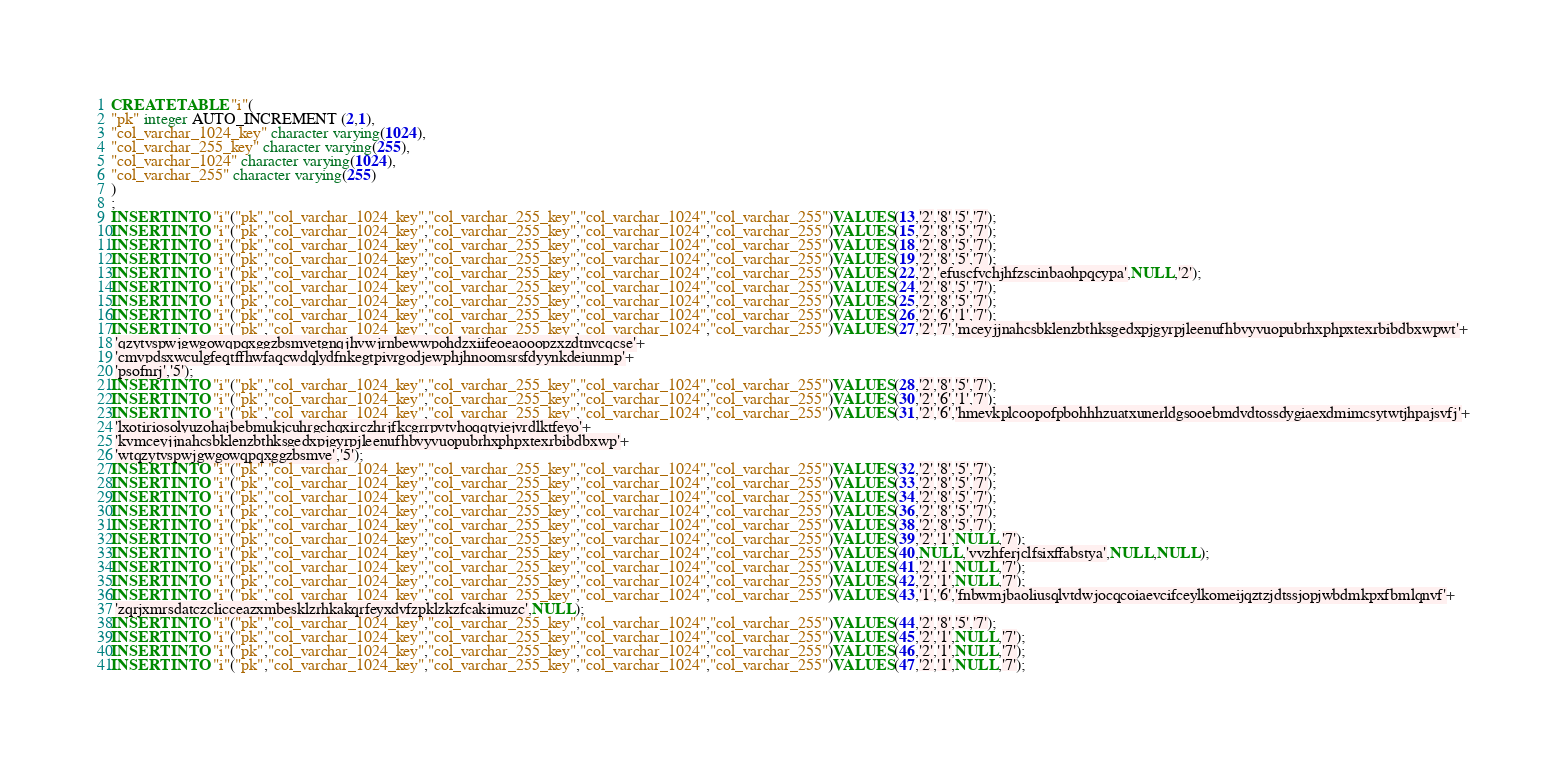Convert code to text. <code><loc_0><loc_0><loc_500><loc_500><_SQL_>CREATE TABLE "i"(
"pk" integer AUTO_INCREMENT (2,1),
"col_varchar_1024_key" character varying(1024),
"col_varchar_255_key" character varying(255),
"col_varchar_1024" character varying(1024),
"col_varchar_255" character varying(255)
)
;
INSERT INTO "i"("pk","col_varchar_1024_key","col_varchar_255_key","col_varchar_1024","col_varchar_255")VALUES(13,'2','8','5','7');
INSERT INTO "i"("pk","col_varchar_1024_key","col_varchar_255_key","col_varchar_1024","col_varchar_255")VALUES(15,'2','8','5','7');
INSERT INTO "i"("pk","col_varchar_1024_key","col_varchar_255_key","col_varchar_1024","col_varchar_255")VALUES(18,'2','8','5','7');
INSERT INTO "i"("pk","col_varchar_1024_key","col_varchar_255_key","col_varchar_1024","col_varchar_255")VALUES(19,'2','8','5','7');
INSERT INTO "i"("pk","col_varchar_1024_key","col_varchar_255_key","col_varchar_1024","col_varchar_255")VALUES(22,'2','efuscfvchjhfzscinbaohpqcypa',NULL,'2');
INSERT INTO "i"("pk","col_varchar_1024_key","col_varchar_255_key","col_varchar_1024","col_varchar_255")VALUES(24,'2','8','5','7');
INSERT INTO "i"("pk","col_varchar_1024_key","col_varchar_255_key","col_varchar_1024","col_varchar_255")VALUES(25,'2','8','5','7');
INSERT INTO "i"("pk","col_varchar_1024_key","col_varchar_255_key","col_varchar_1024","col_varchar_255")VALUES(26,'2','6','1','7');
INSERT INTO "i"("pk","col_varchar_1024_key","col_varchar_255_key","col_varchar_1024","col_varchar_255")VALUES(27,'2','7','mceyjjnahcsbklenzbthksgedxpjgyrpjleenufhbvyvuopubrhxphpxtexrbibdbxwpwt'+
 'qzytvspwjgwgowqpqxggzbsmvetgnqjhvwjrnbewwpohdzxiifeoeaooopzxzdtnvcqcse'+
 'cmvpdsxwculgfeqtffhwfaqcwdqlydfnkegtpivrgodjewphjhnoomsrsfdyynkdeiunmp'+
 'psofnrj','5');
INSERT INTO "i"("pk","col_varchar_1024_key","col_varchar_255_key","col_varchar_1024","col_varchar_255")VALUES(28,'2','8','5','7');
INSERT INTO "i"("pk","col_varchar_1024_key","col_varchar_255_key","col_varchar_1024","col_varchar_255")VALUES(30,'2','6','1','7');
INSERT INTO "i"("pk","col_varchar_1024_key","col_varchar_255_key","col_varchar_1024","col_varchar_255")VALUES(31,'2','6','hmevkplcoopofpbohhhzuatxunerldgsooebmdvdtossdygiaexdmimcsytwtjhpajsvfj'+
 'lxotiriosolyuzohajbebmukjcuhrgchqxirczhrjfkcgrrpvtvhoqqtyiejvrdlktfeyo'+
 'kvmceyjjnahcsbklenzbthksgedxpjgyrpjleenufhbvyvuopubrhxphpxtexrbibdbxwp'+
 'wtqzytvspwjgwgowqpqxggzbsmve','5');
INSERT INTO "i"("pk","col_varchar_1024_key","col_varchar_255_key","col_varchar_1024","col_varchar_255")VALUES(32,'2','8','5','7');
INSERT INTO "i"("pk","col_varchar_1024_key","col_varchar_255_key","col_varchar_1024","col_varchar_255")VALUES(33,'2','8','5','7');
INSERT INTO "i"("pk","col_varchar_1024_key","col_varchar_255_key","col_varchar_1024","col_varchar_255")VALUES(34,'2','8','5','7');
INSERT INTO "i"("pk","col_varchar_1024_key","col_varchar_255_key","col_varchar_1024","col_varchar_255")VALUES(36,'2','8','5','7');
INSERT INTO "i"("pk","col_varchar_1024_key","col_varchar_255_key","col_varchar_1024","col_varchar_255")VALUES(38,'2','8','5','7');
INSERT INTO "i"("pk","col_varchar_1024_key","col_varchar_255_key","col_varchar_1024","col_varchar_255")VALUES(39,'2','1',NULL,'7');
INSERT INTO "i"("pk","col_varchar_1024_key","col_varchar_255_key","col_varchar_1024","col_varchar_255")VALUES(40,NULL,'vvzhferjclfsixffabstya',NULL,NULL);
INSERT INTO "i"("pk","col_varchar_1024_key","col_varchar_255_key","col_varchar_1024","col_varchar_255")VALUES(41,'2','1',NULL,'7');
INSERT INTO "i"("pk","col_varchar_1024_key","col_varchar_255_key","col_varchar_1024","col_varchar_255")VALUES(42,'2','1',NULL,'7');
INSERT INTO "i"("pk","col_varchar_1024_key","col_varchar_255_key","col_varchar_1024","col_varchar_255")VALUES(43,'1','6','fnbwmjbaoliusqlvtdwjocqcoiaevcifceylkomeijqztzjdtssjopjwbdmkpxfbmlqnvf'+
 'zqrjxmrsdatczclicceazxmbesklzrhkakqrfeyxdvfzpklzkzfcakimuzc',NULL);
INSERT INTO "i"("pk","col_varchar_1024_key","col_varchar_255_key","col_varchar_1024","col_varchar_255")VALUES(44,'2','8','5','7');
INSERT INTO "i"("pk","col_varchar_1024_key","col_varchar_255_key","col_varchar_1024","col_varchar_255")VALUES(45,'2','1',NULL,'7');
INSERT INTO "i"("pk","col_varchar_1024_key","col_varchar_255_key","col_varchar_1024","col_varchar_255")VALUES(46,'2','1',NULL,'7');
INSERT INTO "i"("pk","col_varchar_1024_key","col_varchar_255_key","col_varchar_1024","col_varchar_255")VALUES(47,'2','1',NULL,'7');</code> 